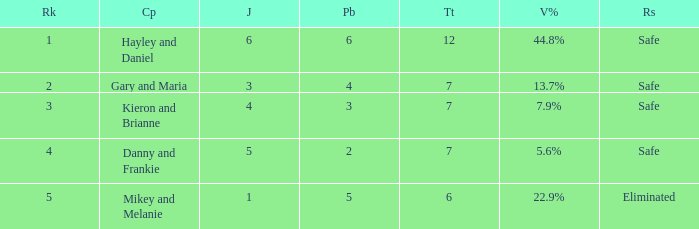How many judges were there for the eliminated couple?  1.0. 